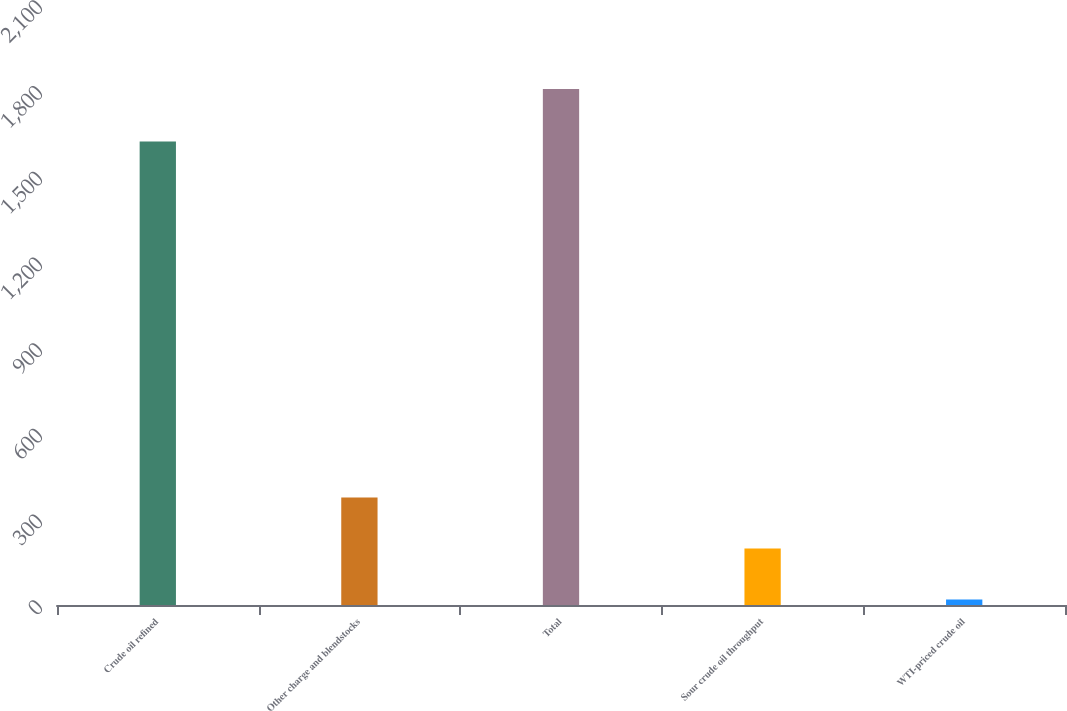Convert chart to OTSL. <chart><loc_0><loc_0><loc_500><loc_500><bar_chart><fcel>Crude oil refined<fcel>Other charge and blendstocks<fcel>Total<fcel>Sour crude oil throughput<fcel>WTI-priced crude oil<nl><fcel>1622<fcel>376.4<fcel>1806<fcel>197.7<fcel>19<nl></chart> 